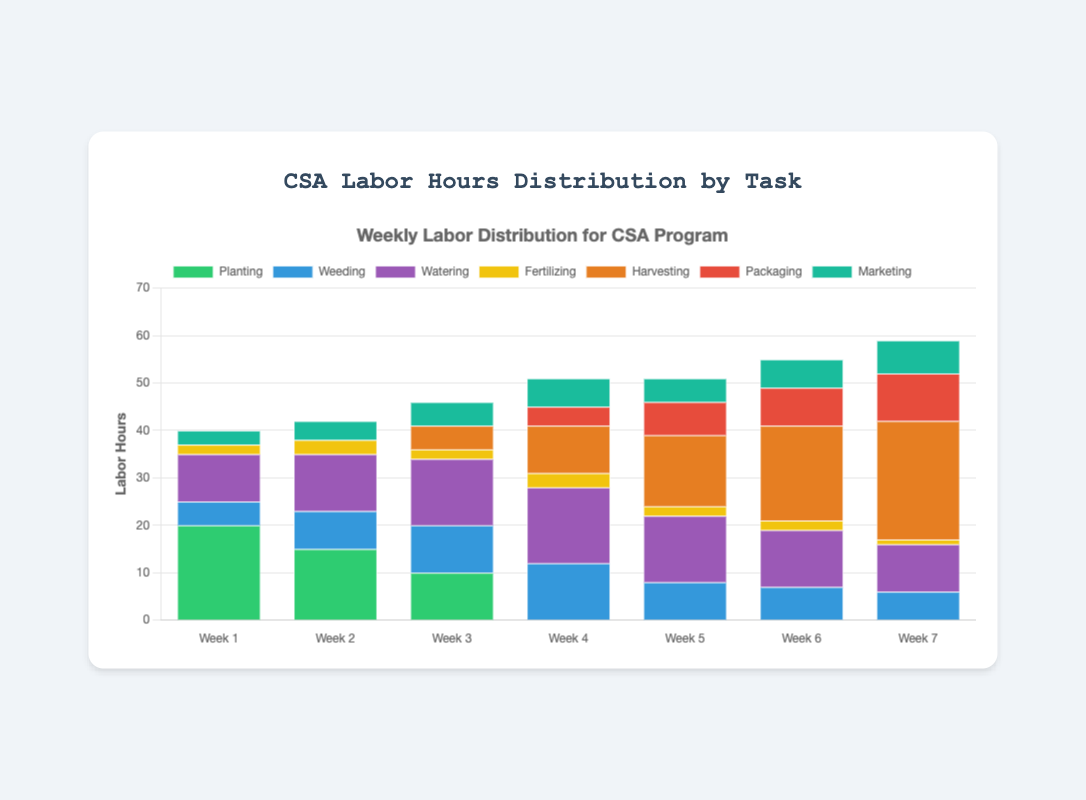Which week had the highest total labor hours? To find which week had the highest total labor hours, sum the hours for each task per week and compare the totals. For example, Week 1 had 20+5+10+2+0+0+3 = 40 hours, Week 2 had 44 hours, Week 3 had 46 hours, Week 4 had 51 hours, Week 5 had 51 hours, Week 6 had 55 hours, and Week 7 had 59 hours. Week 7 had the highest total.
Answer: Week 7 Which task required the most hours in Week 4? Look at the bar representing Week 4 and compare the heights/colors of segments corresponding to each task. We can see that Watering has the highest number of hours in Week 4.
Answer: Watering How many total hours were spent on Weeding over the 7 weeks? Sum the hours spent on Weeding for each week: 5 + 8 + 10 + 12 + 8 + 7 + 6 = 56 hours.
Answer: 56 By how many hours did the Harvesting task increase from Week 5 to Week 6? Compare the height of the Harvesting bar for Week 5 and Week 6. Week 5 has 15 hours and Week 6 has 20 hours. The increase is 20 - 15 = 5 hours.
Answer: 5 Which task shows a decreasing trend in hours from Week 1 to Week 7? Observe the slope and length of the bars for each task. Planting shows a decreasing trend, starting from 20 hours in Week 1 and decreasing to 0 hours by Week 4 and staying at 0 hours.
Answer: Planting What is the average number of hours spent on Watering per week? Sum the hours spent on Watering for each week and divide by the number of weeks. (10 + 12 + 14 + 16 + 14 + 12 + 10) / 7 = 88 / 7 ≈ 12.57 hours per week.
Answer: ~12.57 Which task appeared first in the labor hours and then disappeared by the end? Look at the consistent existence and absence of tasks across the weeks. Planting is present from Week 1 to Week 3 but disappears from Week 4 onward.
Answer: Planting In Week 6 and Week 7, which task had more hours: Marketing or Packaging? Compare the height of the bars corresponding to Marketing and Packaging for Week 6 and Week 7. Week 6 has Marketing at 6 hours and Packaging at 8 hours. Week 7 has Marketing at 7 hours and Packaging at 10 hours. In both weeks, Packaging had more hours.
Answer: Packaging Which week marks the first appearance of Packaging labor hours? Look for the week where the Packaging hours first appear. Packaging starts in Week 4 with 4 hours.
Answer: Week 4 